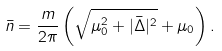<formula> <loc_0><loc_0><loc_500><loc_500>\bar { n } = \frac { m } { 2 \pi } \left ( \sqrt { \mu _ { 0 } ^ { 2 } + | \bar { \Delta } | ^ { 2 } } + \mu _ { 0 } \right ) .</formula> 